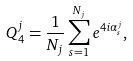Convert formula to latex. <formula><loc_0><loc_0><loc_500><loc_500>Q _ { 4 } ^ { j } = \frac { 1 } { N _ { j } } \sum _ { s = 1 } ^ { N _ { j } } e ^ { 4 i \alpha _ { s } ^ { j } } ,</formula> 